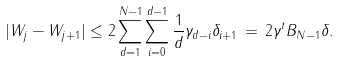<formula> <loc_0><loc_0><loc_500><loc_500>| W _ { j } - W _ { j + 1 } | \leq 2 \sum _ { d = 1 } ^ { N - 1 } \sum _ { i = 0 } ^ { d - 1 } \frac { 1 } { d } \gamma _ { d - i } \delta _ { i + 1 } \, = \, 2 \gamma ^ { t } B _ { N - 1 } \delta .</formula> 